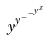Convert formula to latex. <formula><loc_0><loc_0><loc_500><loc_500>y ^ { y ^ { - ^ { - ^ { y ^ { x } } } } }</formula> 